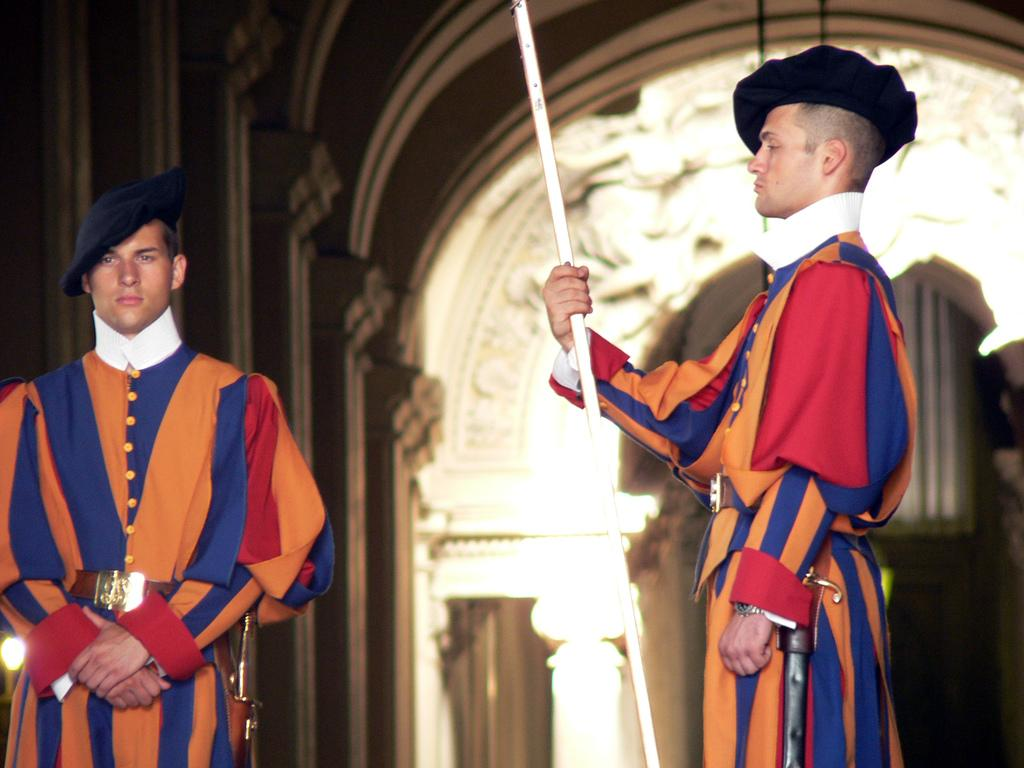What type of structures can be seen in the image? There are buildings in the image. Can you describe the people in the image? There are two people standing in the front of the image. What type of potato is being harvested by the people in the image? There is no potato or any agricultural activity depicted in the image; it features buildings and people standing. What type of growth can be observed in the image? The provided facts do not mention any growth or development; the image only shows buildings and people standing. 